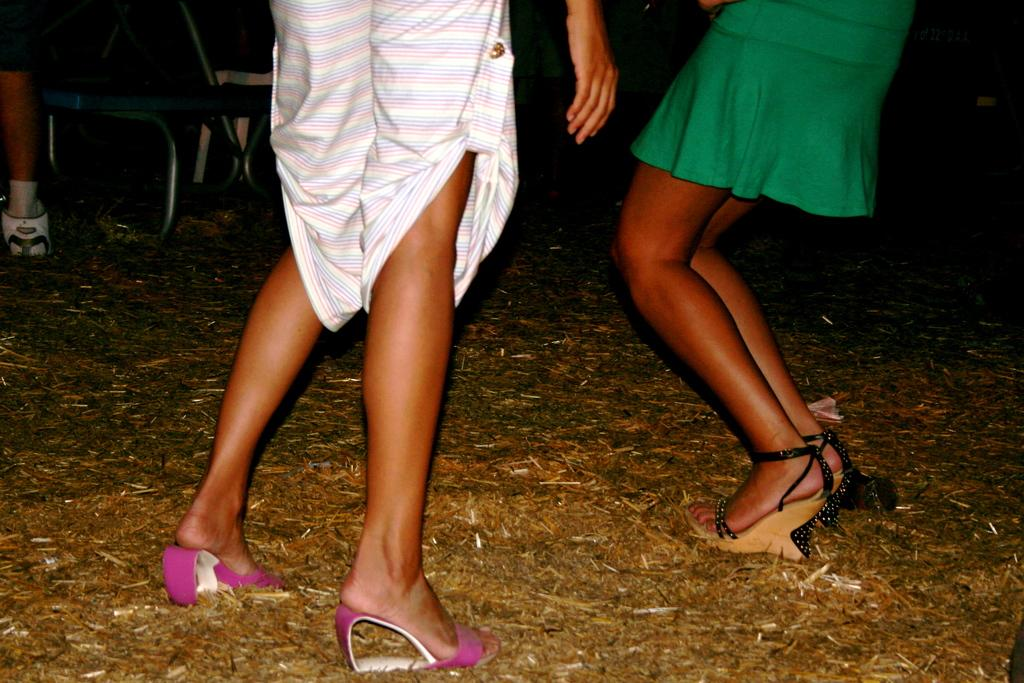What can be seen in the image related to people? There are two persons' legs visible in the image. What is the position of the legs in the image? The legs are standing on the ground. How would you describe the background of the image? The background of the image is dark. Can you describe any objects present in the background? There are objects present in the background of the image, but their specific details are not mentioned in the facts. What type of apparel is the person wearing on their legs in the image? The facts do not mention any specific apparel on the legs, so we cannot determine the type of clothing from the image. What learning materials can be seen in the image? There is no mention of learning materials in the image, as the facts only mention the legs of two persons and the dark background. 